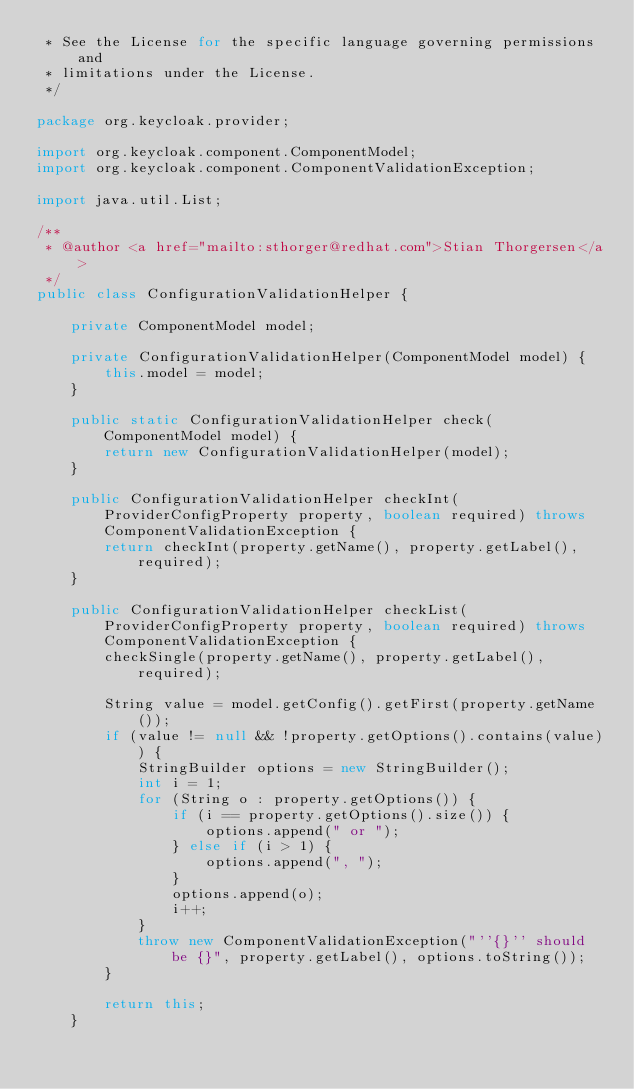<code> <loc_0><loc_0><loc_500><loc_500><_Java_> * See the License for the specific language governing permissions and
 * limitations under the License.
 */

package org.keycloak.provider;

import org.keycloak.component.ComponentModel;
import org.keycloak.component.ComponentValidationException;

import java.util.List;

/**
 * @author <a href="mailto:sthorger@redhat.com">Stian Thorgersen</a>
 */
public class ConfigurationValidationHelper {

    private ComponentModel model;

    private ConfigurationValidationHelper(ComponentModel model) {
        this.model = model;
    }

    public static ConfigurationValidationHelper check(ComponentModel model) {
        return new ConfigurationValidationHelper(model);
    }

    public ConfigurationValidationHelper checkInt(ProviderConfigProperty property, boolean required) throws ComponentValidationException {
        return checkInt(property.getName(), property.getLabel(), required);
    }

    public ConfigurationValidationHelper checkList(ProviderConfigProperty property, boolean required) throws ComponentValidationException {
        checkSingle(property.getName(), property.getLabel(), required);

        String value = model.getConfig().getFirst(property.getName());
        if (value != null && !property.getOptions().contains(value)) {
            StringBuilder options = new StringBuilder();
            int i = 1;
            for (String o : property.getOptions()) {
                if (i == property.getOptions().size()) {
                    options.append(" or ");
                } else if (i > 1) {
                    options.append(", ");
                }
                options.append(o);
                i++;
            }
            throw new ComponentValidationException("''{}'' should be {}", property.getLabel(), options.toString());
        }

        return this;
    }
</code> 